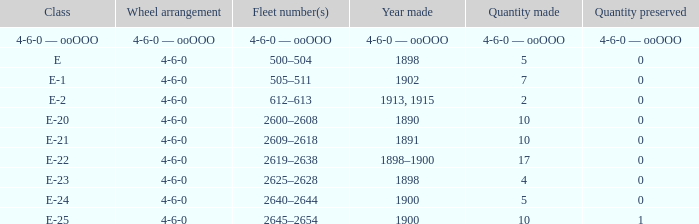What is the amount produced of the e-22 class, which has a preserved amount of 0? 17.0. 